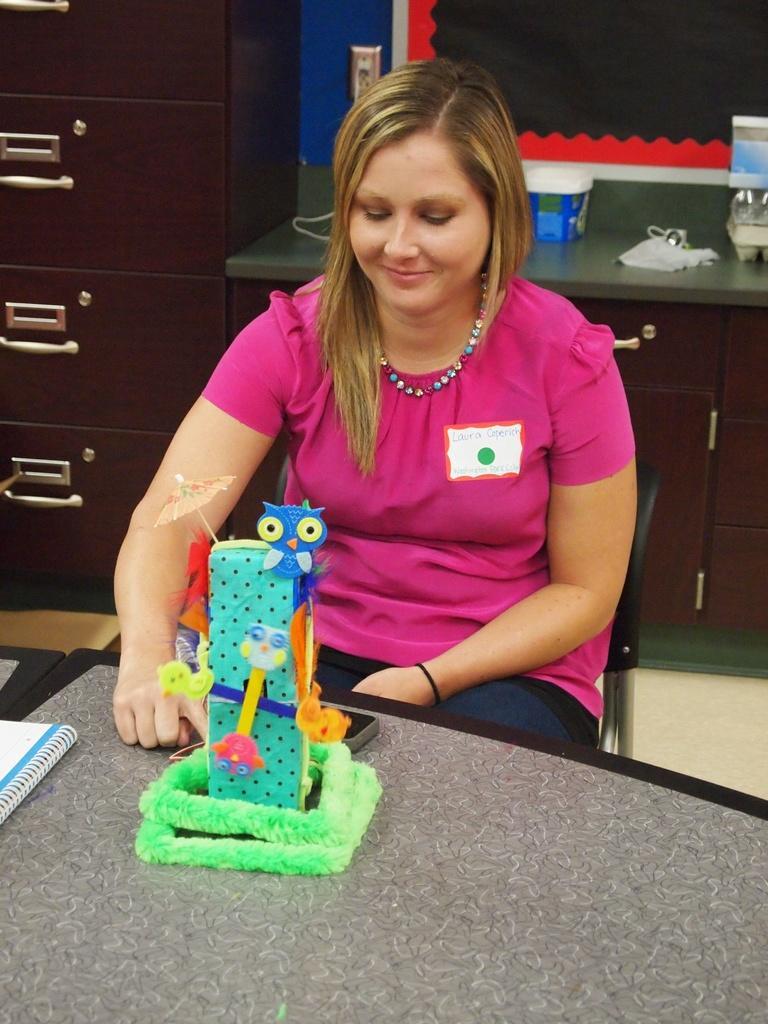Describe this image in one or two sentences. In this picture I can see a book and a toy on the table, there is a woman sitting on the chair, and in the background there are some objects on the cabinet and there is a cupboard. 